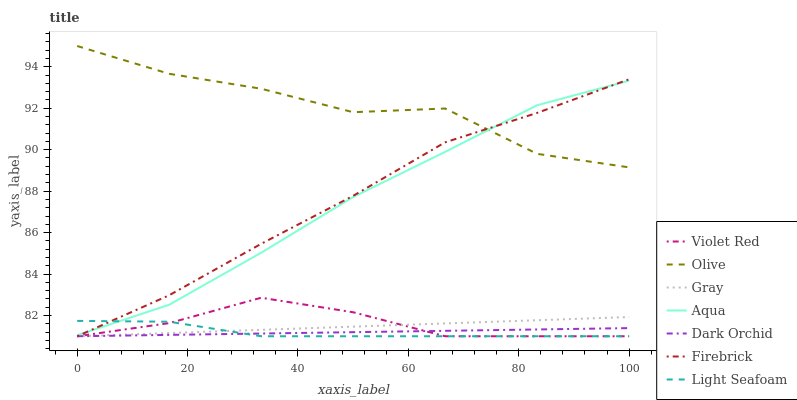Does Light Seafoam have the minimum area under the curve?
Answer yes or no. Yes. Does Olive have the maximum area under the curve?
Answer yes or no. Yes. Does Violet Red have the minimum area under the curve?
Answer yes or no. No. Does Violet Red have the maximum area under the curve?
Answer yes or no. No. Is Gray the smoothest?
Answer yes or no. Yes. Is Olive the roughest?
Answer yes or no. Yes. Is Violet Red the smoothest?
Answer yes or no. No. Is Violet Red the roughest?
Answer yes or no. No. Does Gray have the lowest value?
Answer yes or no. Yes. Does Aqua have the lowest value?
Answer yes or no. No. Does Olive have the highest value?
Answer yes or no. Yes. Does Violet Red have the highest value?
Answer yes or no. No. Is Dark Orchid less than Olive?
Answer yes or no. Yes. Is Olive greater than Gray?
Answer yes or no. Yes. Does Dark Orchid intersect Firebrick?
Answer yes or no. Yes. Is Dark Orchid less than Firebrick?
Answer yes or no. No. Is Dark Orchid greater than Firebrick?
Answer yes or no. No. Does Dark Orchid intersect Olive?
Answer yes or no. No. 